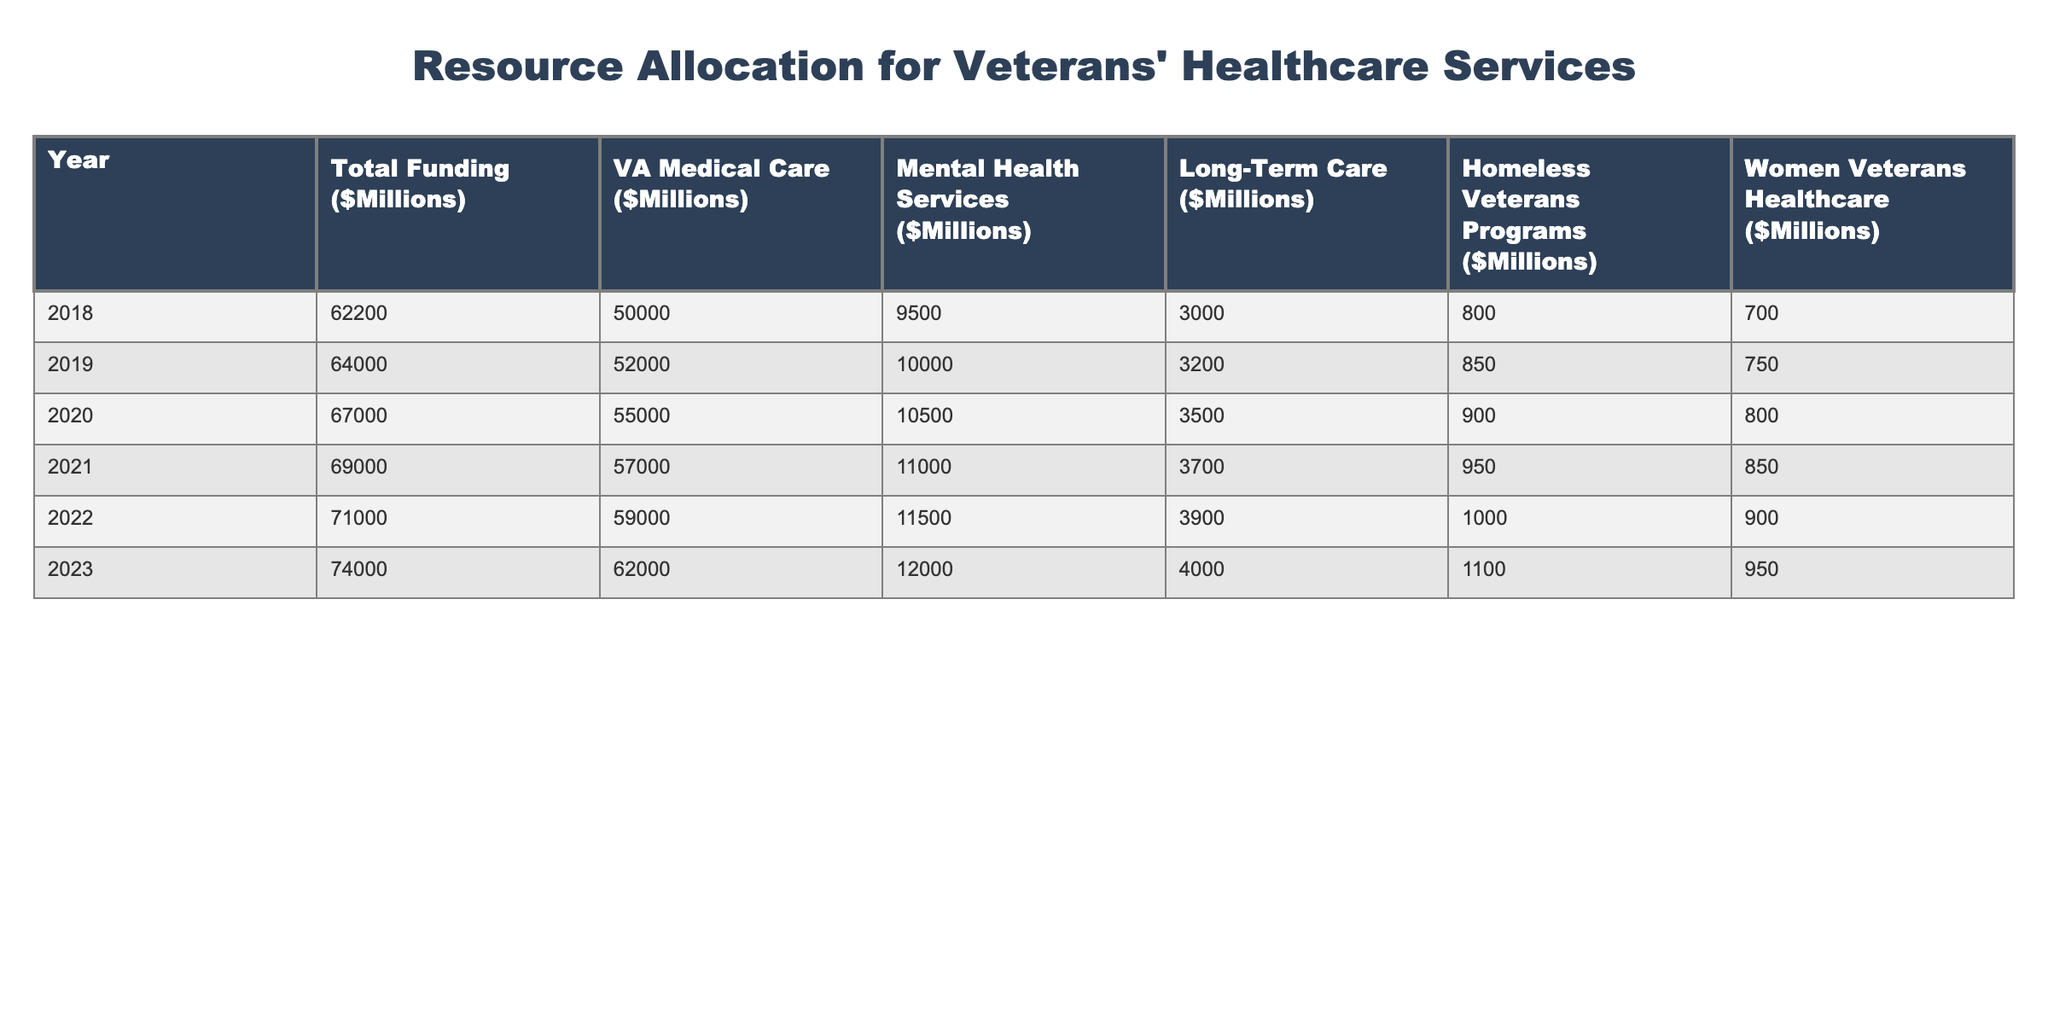What was the total funding for veterans' healthcare services in 2020? In the table, under the column "Total Funding ($Millions)" for the year 2020, the value is 67000.
Answer: 67000 What is the amount allocated for mental health services in 2023? Referring to the table, the allocation for mental health services in the year 2023 is 12000.
Answer: 12000 Did the funding for homeless veterans programs increase from 2018 to 2023? To find this, we look at the corresponding figures for homeless veterans programs: in 2018 the amount was 800, and in 2023 it is 1100. Since 1100 is greater than 800, the statement is true.
Answer: Yes What was the average allocation for women veterans' healthcare services over the years 2018 to 2023? Summing the amounts allocated for women veterans' healthcare services from 2018 to 2023 (700 + 750 + 800 + 850 + 900 + 950) gives us 4150. There are 6 years, so we divide this by 6: 4150 / 6 = approximately 691.67.
Answer: Approximately 691.67 Which year experienced the largest increase in total funding compared to the previous year? By calculating the yearly differences in total funding: from 2018 to 2019, the increase was 800; from 2019 to 2020, it was 3000; from 2020 to 2021, it was 2000; from 2021 to 2022, it was 2000; and from 2022 to 2023, it was 3000. The largest increase occurred from 2019 to 2020, which was 3000.
Answer: 3000 